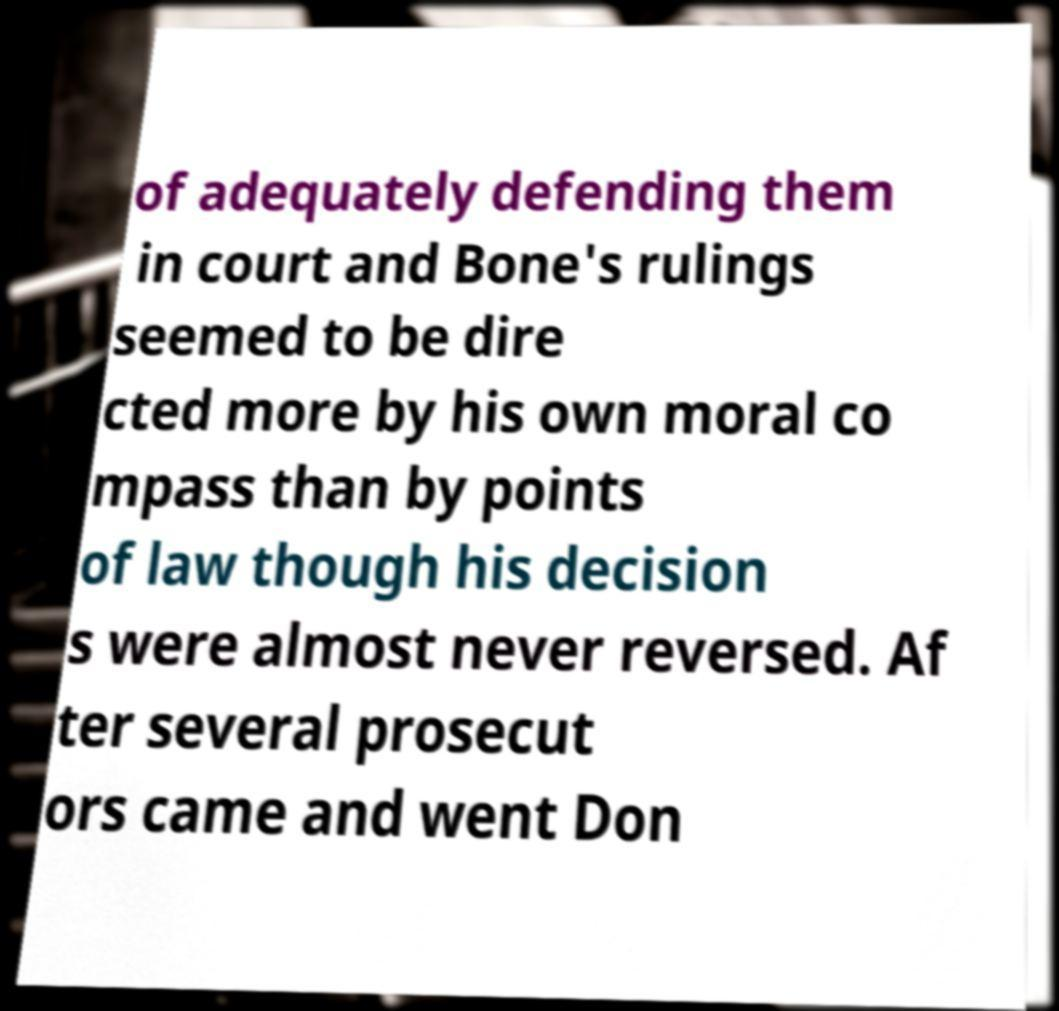I need the written content from this picture converted into text. Can you do that? of adequately defending them in court and Bone's rulings seemed to be dire cted more by his own moral co mpass than by points of law though his decision s were almost never reversed. Af ter several prosecut ors came and went Don 